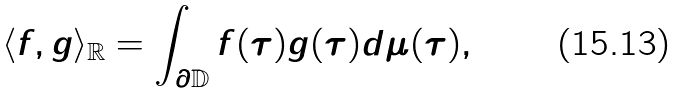<formula> <loc_0><loc_0><loc_500><loc_500>\langle f , g \rangle _ { \mathbb { R } } = \int _ { \partial \mathbb { D } } f ( \tau ) g ( \tau ) d \mu ( \tau ) ,</formula> 